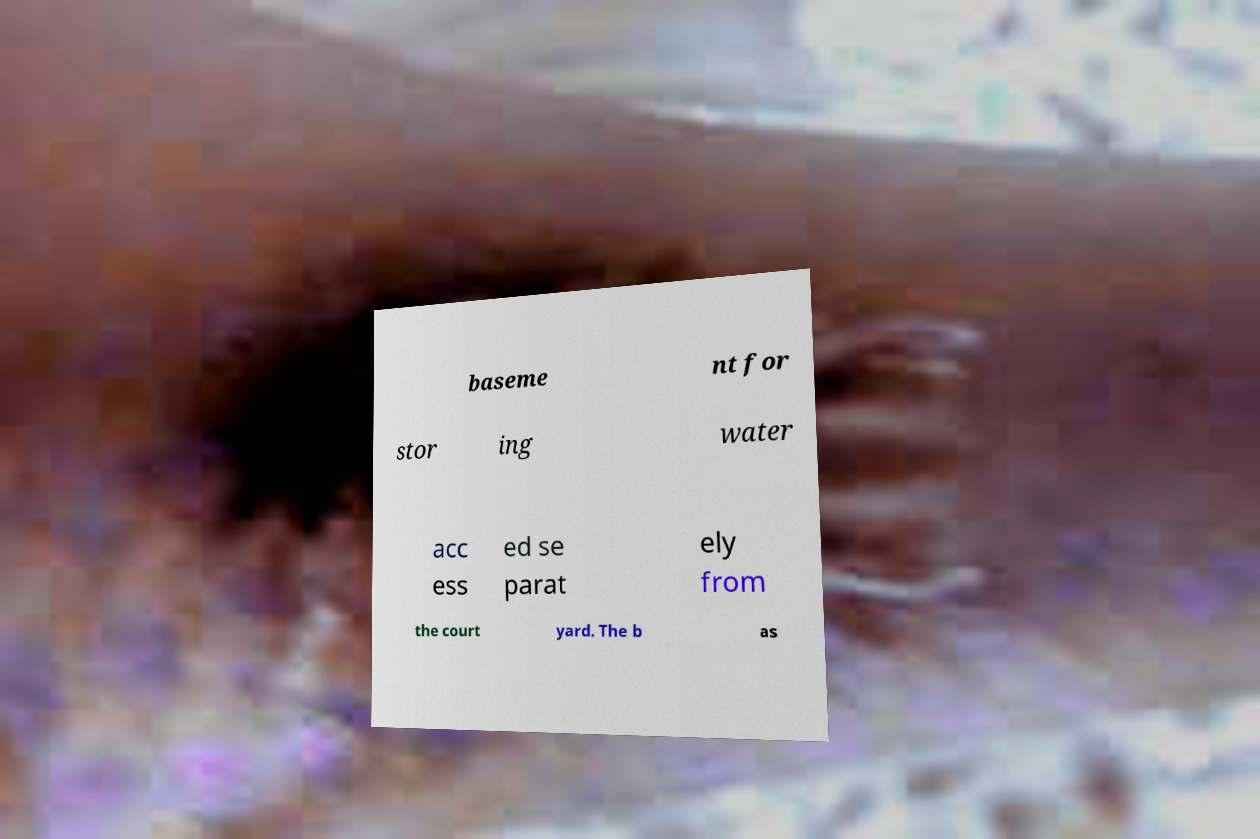Can you accurately transcribe the text from the provided image for me? baseme nt for stor ing water acc ess ed se parat ely from the court yard. The b as 